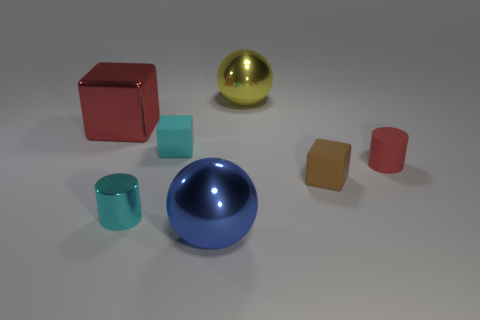Subtract all matte blocks. How many blocks are left? 1 Add 2 tiny cyan matte blocks. How many objects exist? 9 Subtract all cylinders. How many objects are left? 5 Add 2 tiny cylinders. How many tiny cylinders are left? 4 Add 3 small cyan metal cylinders. How many small cyan metal cylinders exist? 4 Subtract 0 brown cylinders. How many objects are left? 7 Subtract all big yellow shiny balls. Subtract all rubber cubes. How many objects are left? 4 